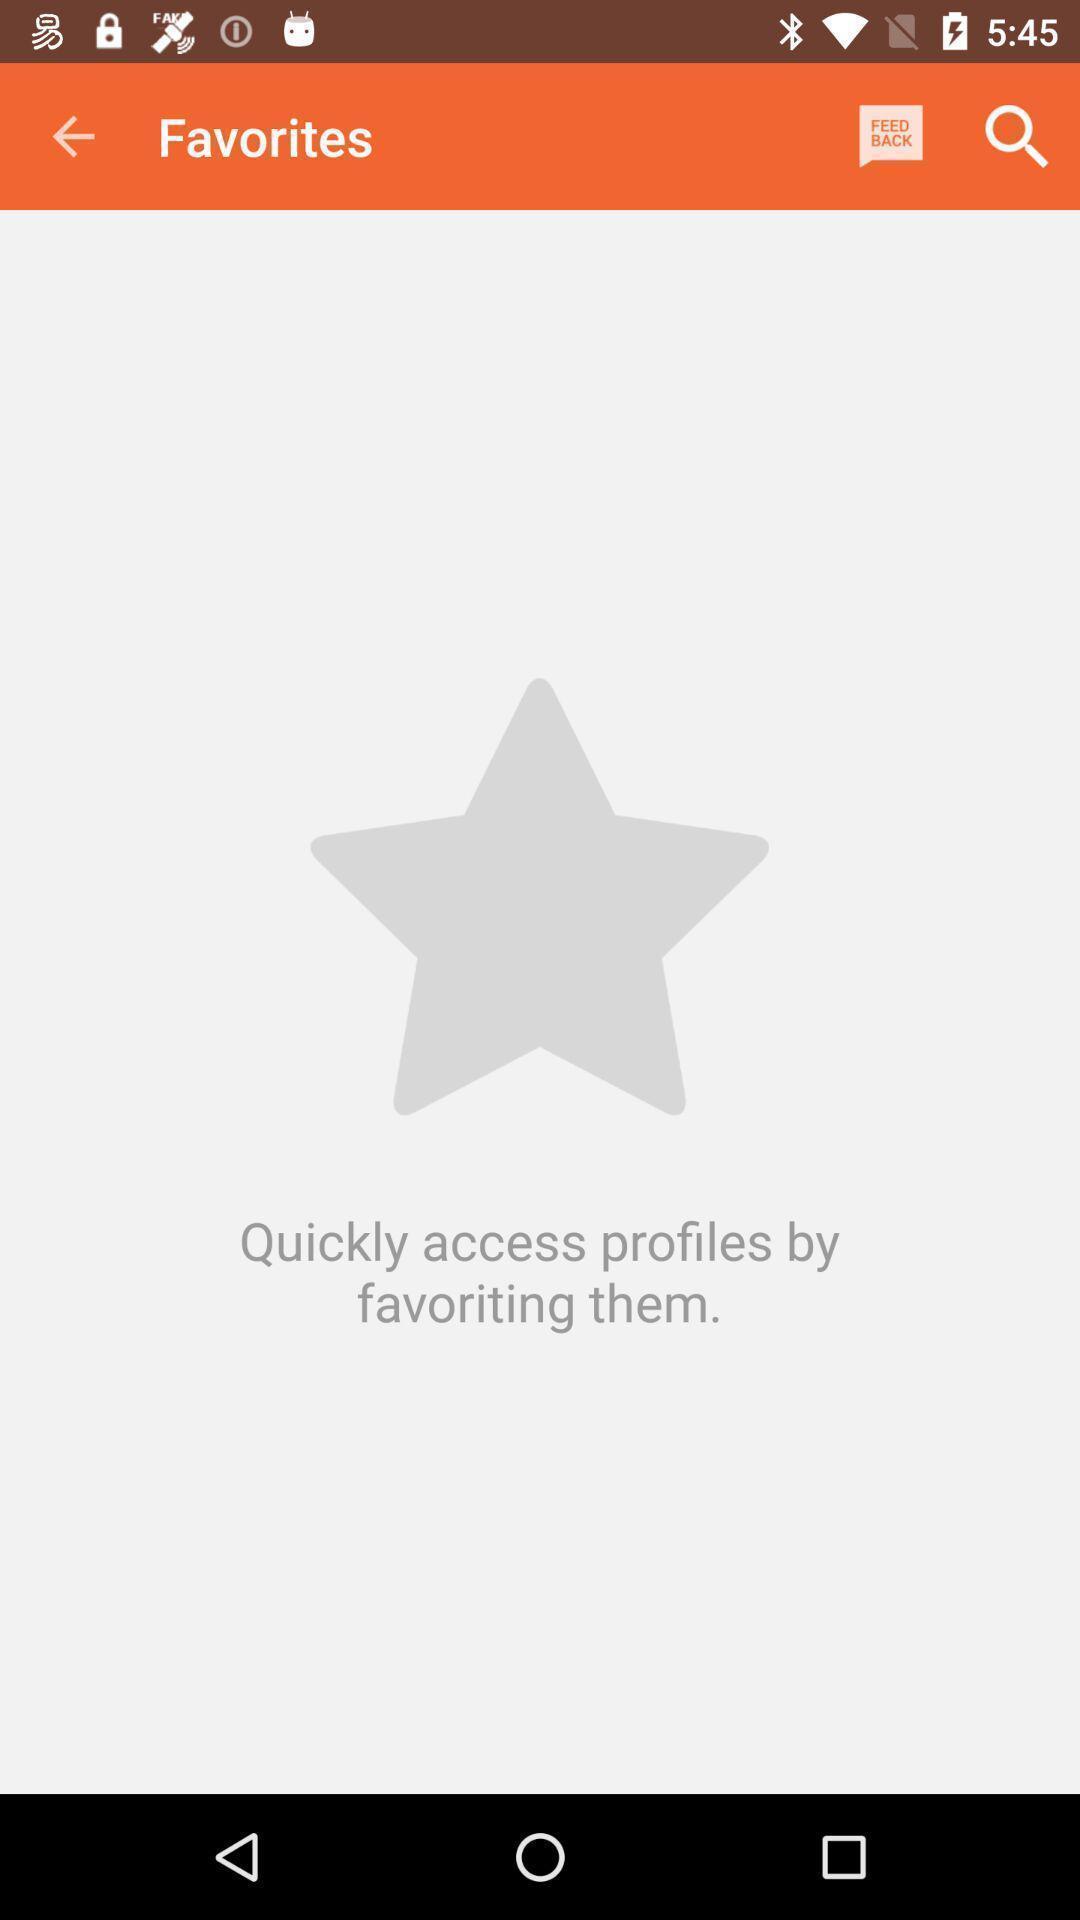Tell me about the visual elements in this screen capture. Screen shows favourites. 